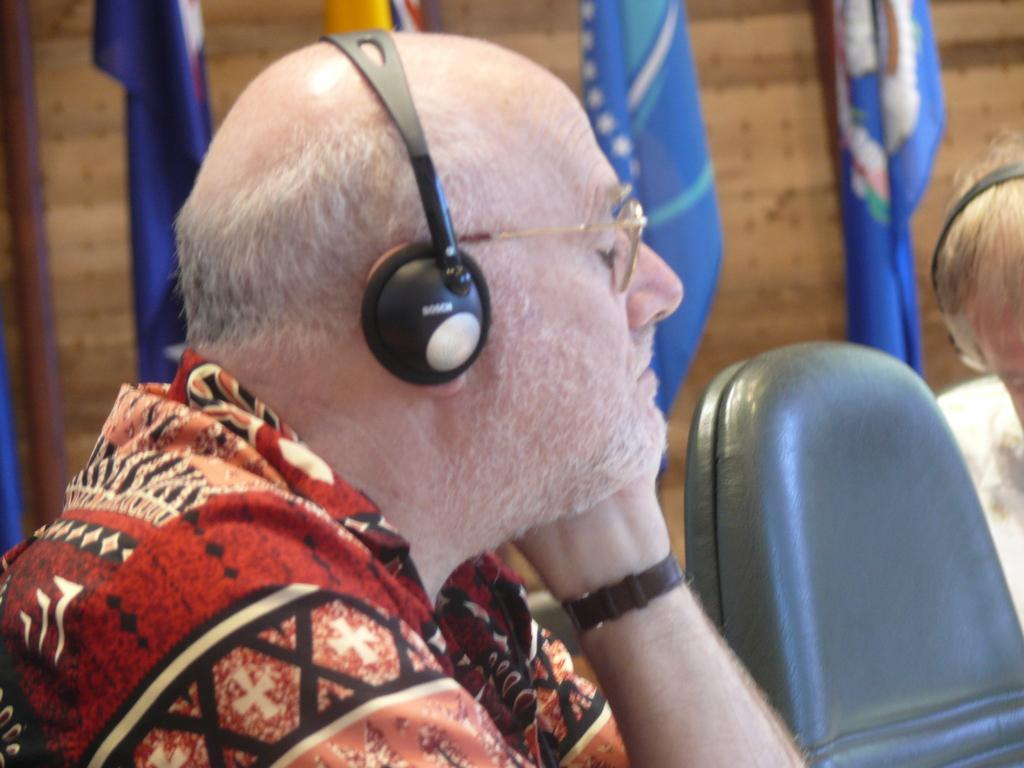Who is present in the image? There is a man in the image. What is the man wearing? The man is wearing headphones. What is the man doing in the image? The man is listening to something. What can be seen beside the man? There are chairs beside the man. What is visible behind the man? There are flags behind the man. Can you tell me how deep the lake is behind the man in the image? There is no lake present in the image; it features flags behind the man. 